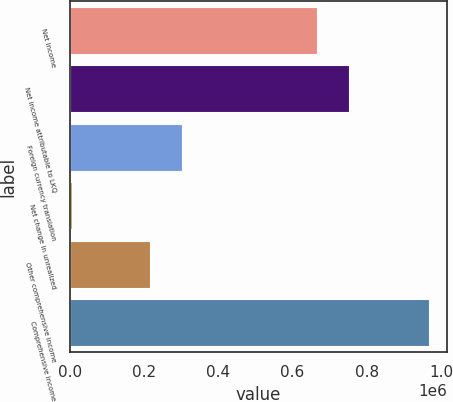Convert chart to OTSL. <chart><loc_0><loc_0><loc_500><loc_500><bar_chart><fcel>Net income<fcel>Net income attributable to LKQ<fcel>Foreign currency translation<fcel>Net change in unrealized<fcel>Other comprehensive income<fcel>Comprehensive income<nl><fcel>665171<fcel>752616<fcel>302760<fcel>6035<fcel>215315<fcel>967931<nl></chart> 